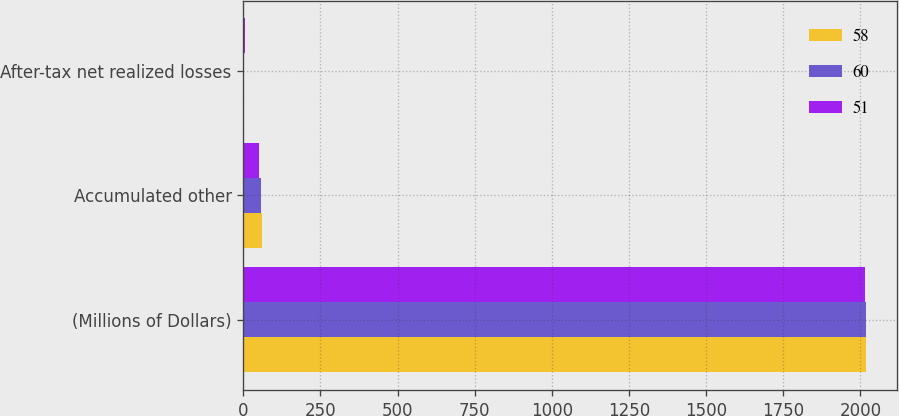<chart> <loc_0><loc_0><loc_500><loc_500><stacked_bar_chart><ecel><fcel>(Millions of Dollars)<fcel>Accumulated other<fcel>After-tax net realized losses<nl><fcel>58<fcel>2018<fcel>60<fcel>3<nl><fcel>60<fcel>2017<fcel>58<fcel>3<nl><fcel>51<fcel>2016<fcel>51<fcel>4<nl></chart> 